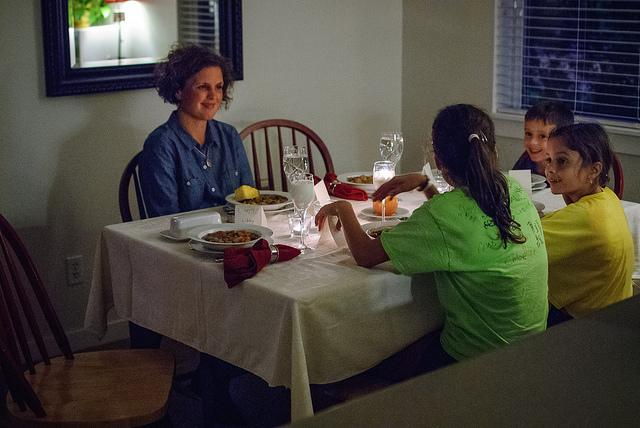What is holding the red napkin together? Please explain your reasoning. napkin ring. There is a silver circle encompassing the red material to keep its shape. 